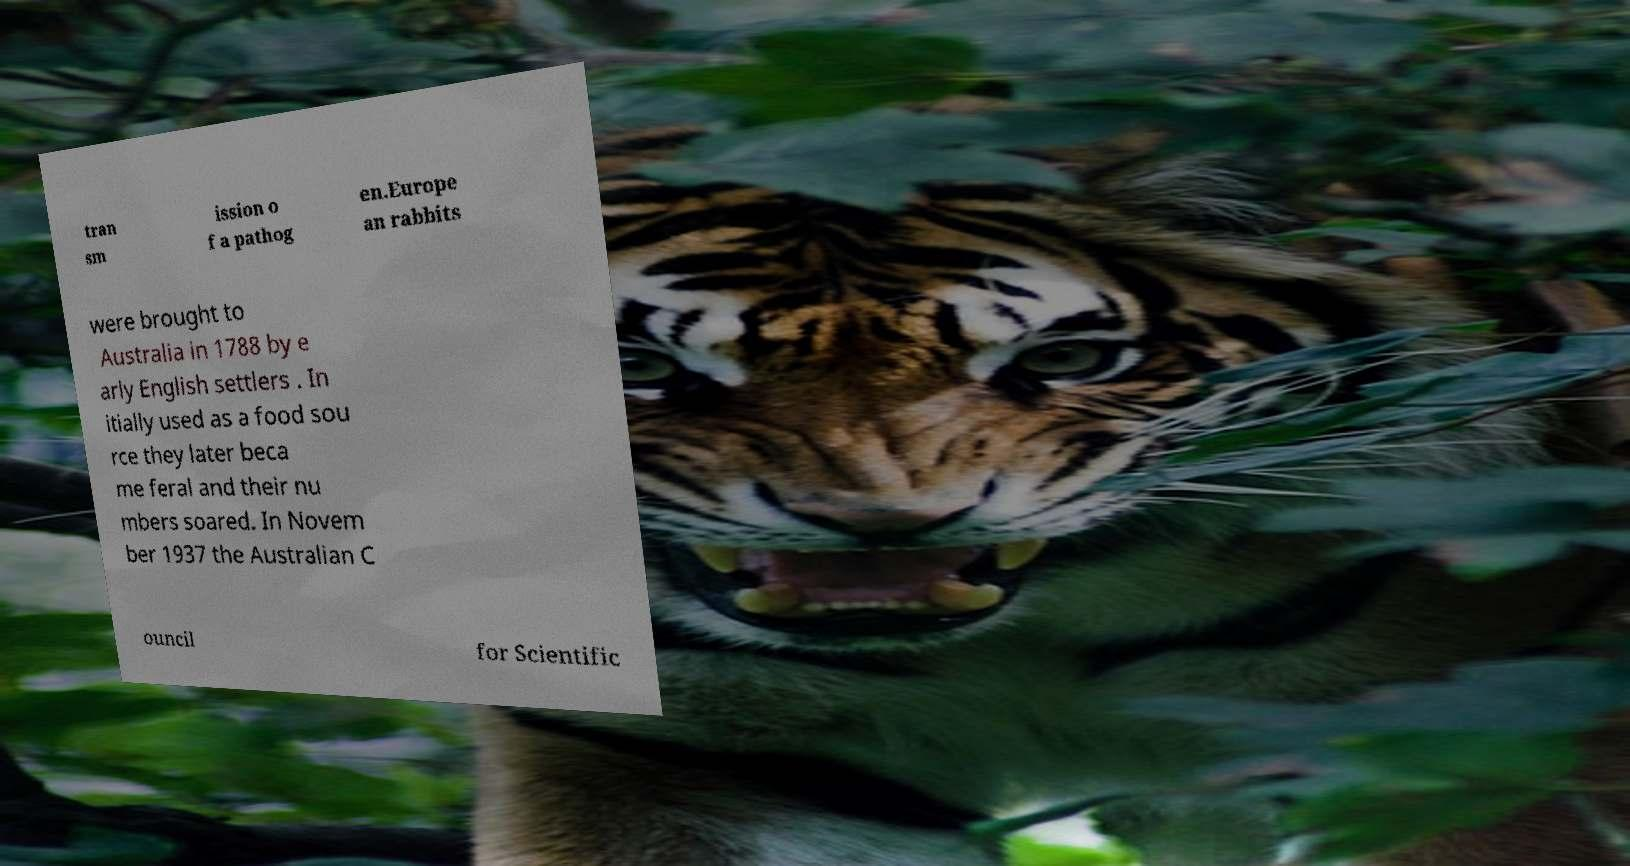Could you extract and type out the text from this image? tran sm ission o f a pathog en.Europe an rabbits were brought to Australia in 1788 by e arly English settlers . In itially used as a food sou rce they later beca me feral and their nu mbers soared. In Novem ber 1937 the Australian C ouncil for Scientific 